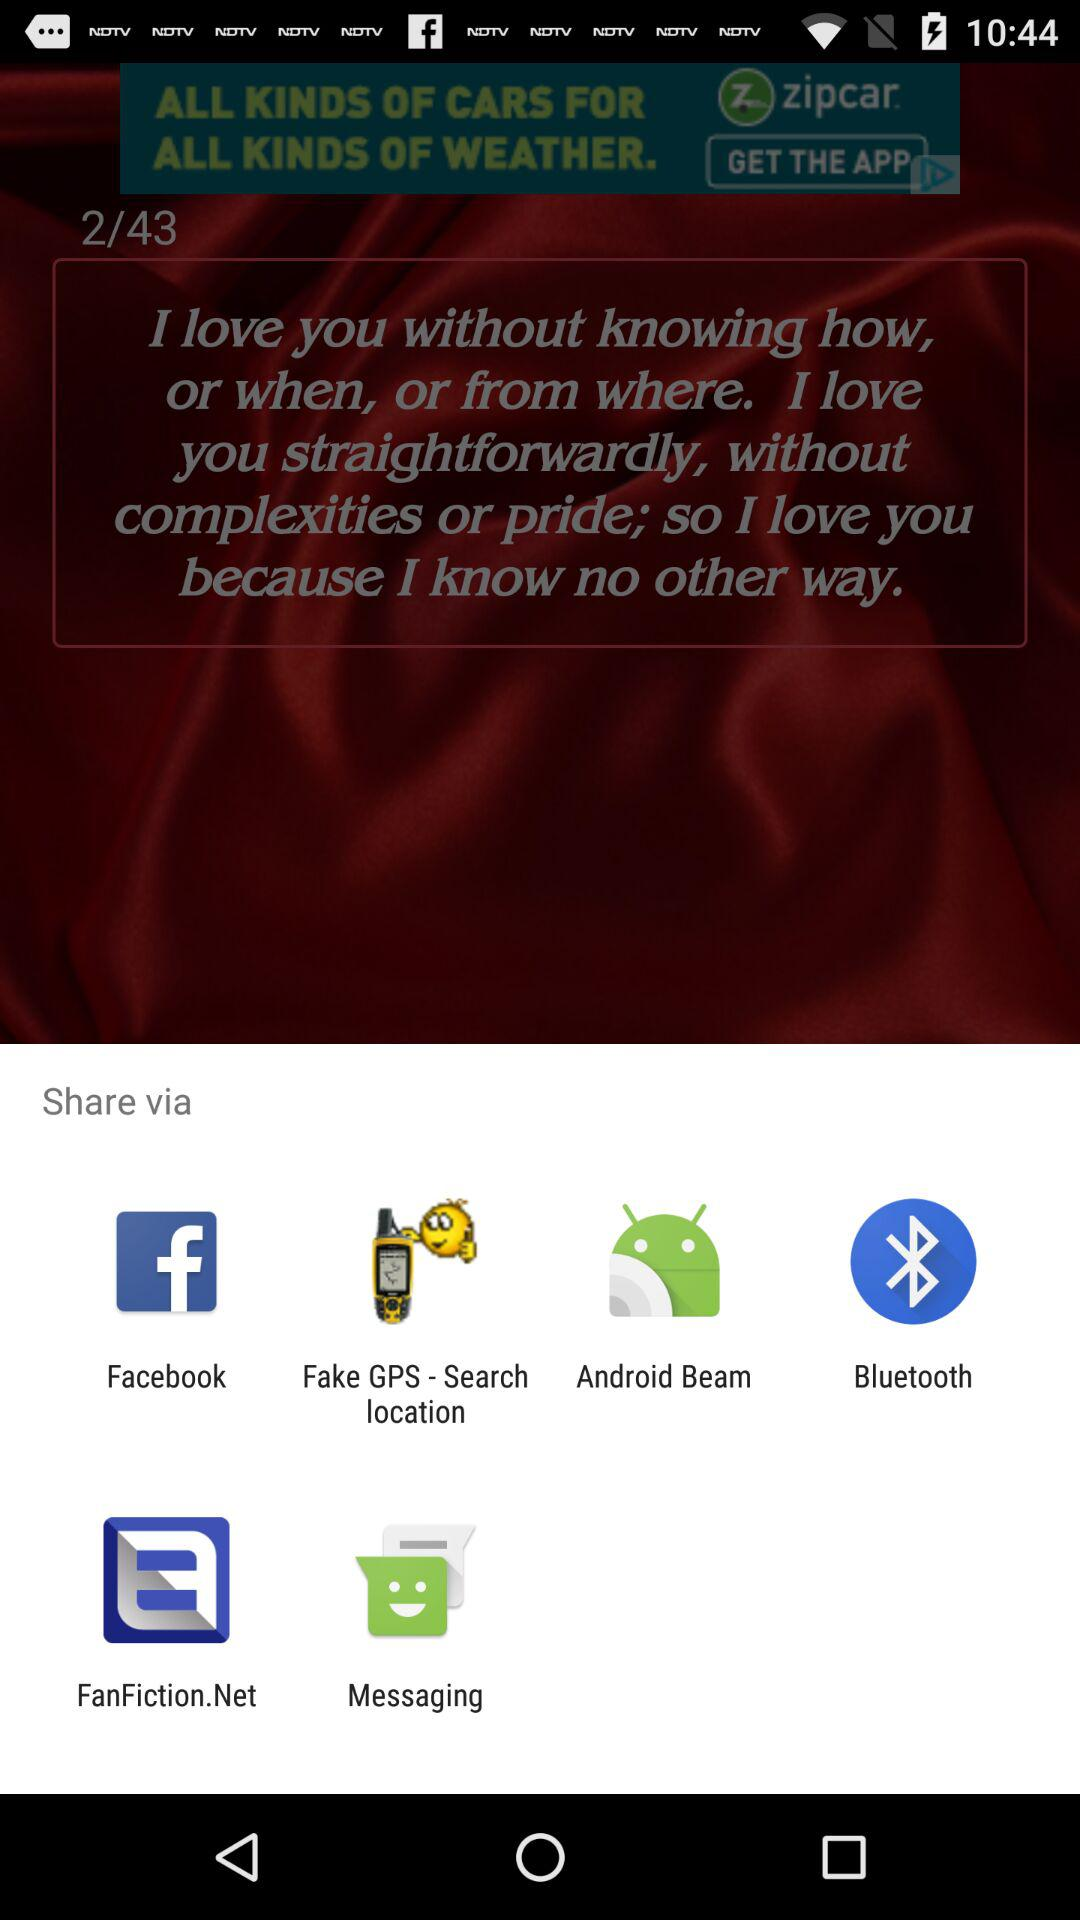Which applications can we use to share? You can use "Facebook", "Fake GPS - Search location", "Android Beam", "Bluetooth", "FanFiction.Net" and "Messaging". 